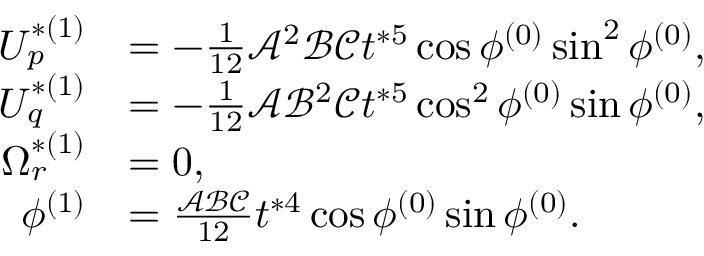Convert formula to latex. <formula><loc_0><loc_0><loc_500><loc_500>\begin{array} { r l } { U _ { p } ^ { * ( 1 ) } } & { = - \frac { 1 } { 1 2 } \mathcal { A } ^ { 2 } \mathcal { B } \mathcal { C } t ^ { * 5 } \cos \phi ^ { ( 0 ) } \sin ^ { 2 } \phi ^ { ( 0 ) } , } \\ { U _ { q } ^ { * ( 1 ) } } & { = - \frac { 1 } { 1 2 } \mathcal { A } \mathcal { B } ^ { 2 } \mathcal { C } t ^ { * 5 } \cos ^ { 2 } \phi ^ { ( 0 ) } \sin \phi ^ { ( 0 ) } , } \\ { \Omega _ { r } ^ { * ( 1 ) } } & { = 0 , } \\ { \phi ^ { ( 1 ) } } & { = \frac { \mathcal { A } \mathcal { B } \mathcal { C } } { 1 2 } t ^ { * 4 } \cos \phi ^ { ( 0 ) } \sin \phi ^ { ( 0 ) } . } \end{array}</formula> 